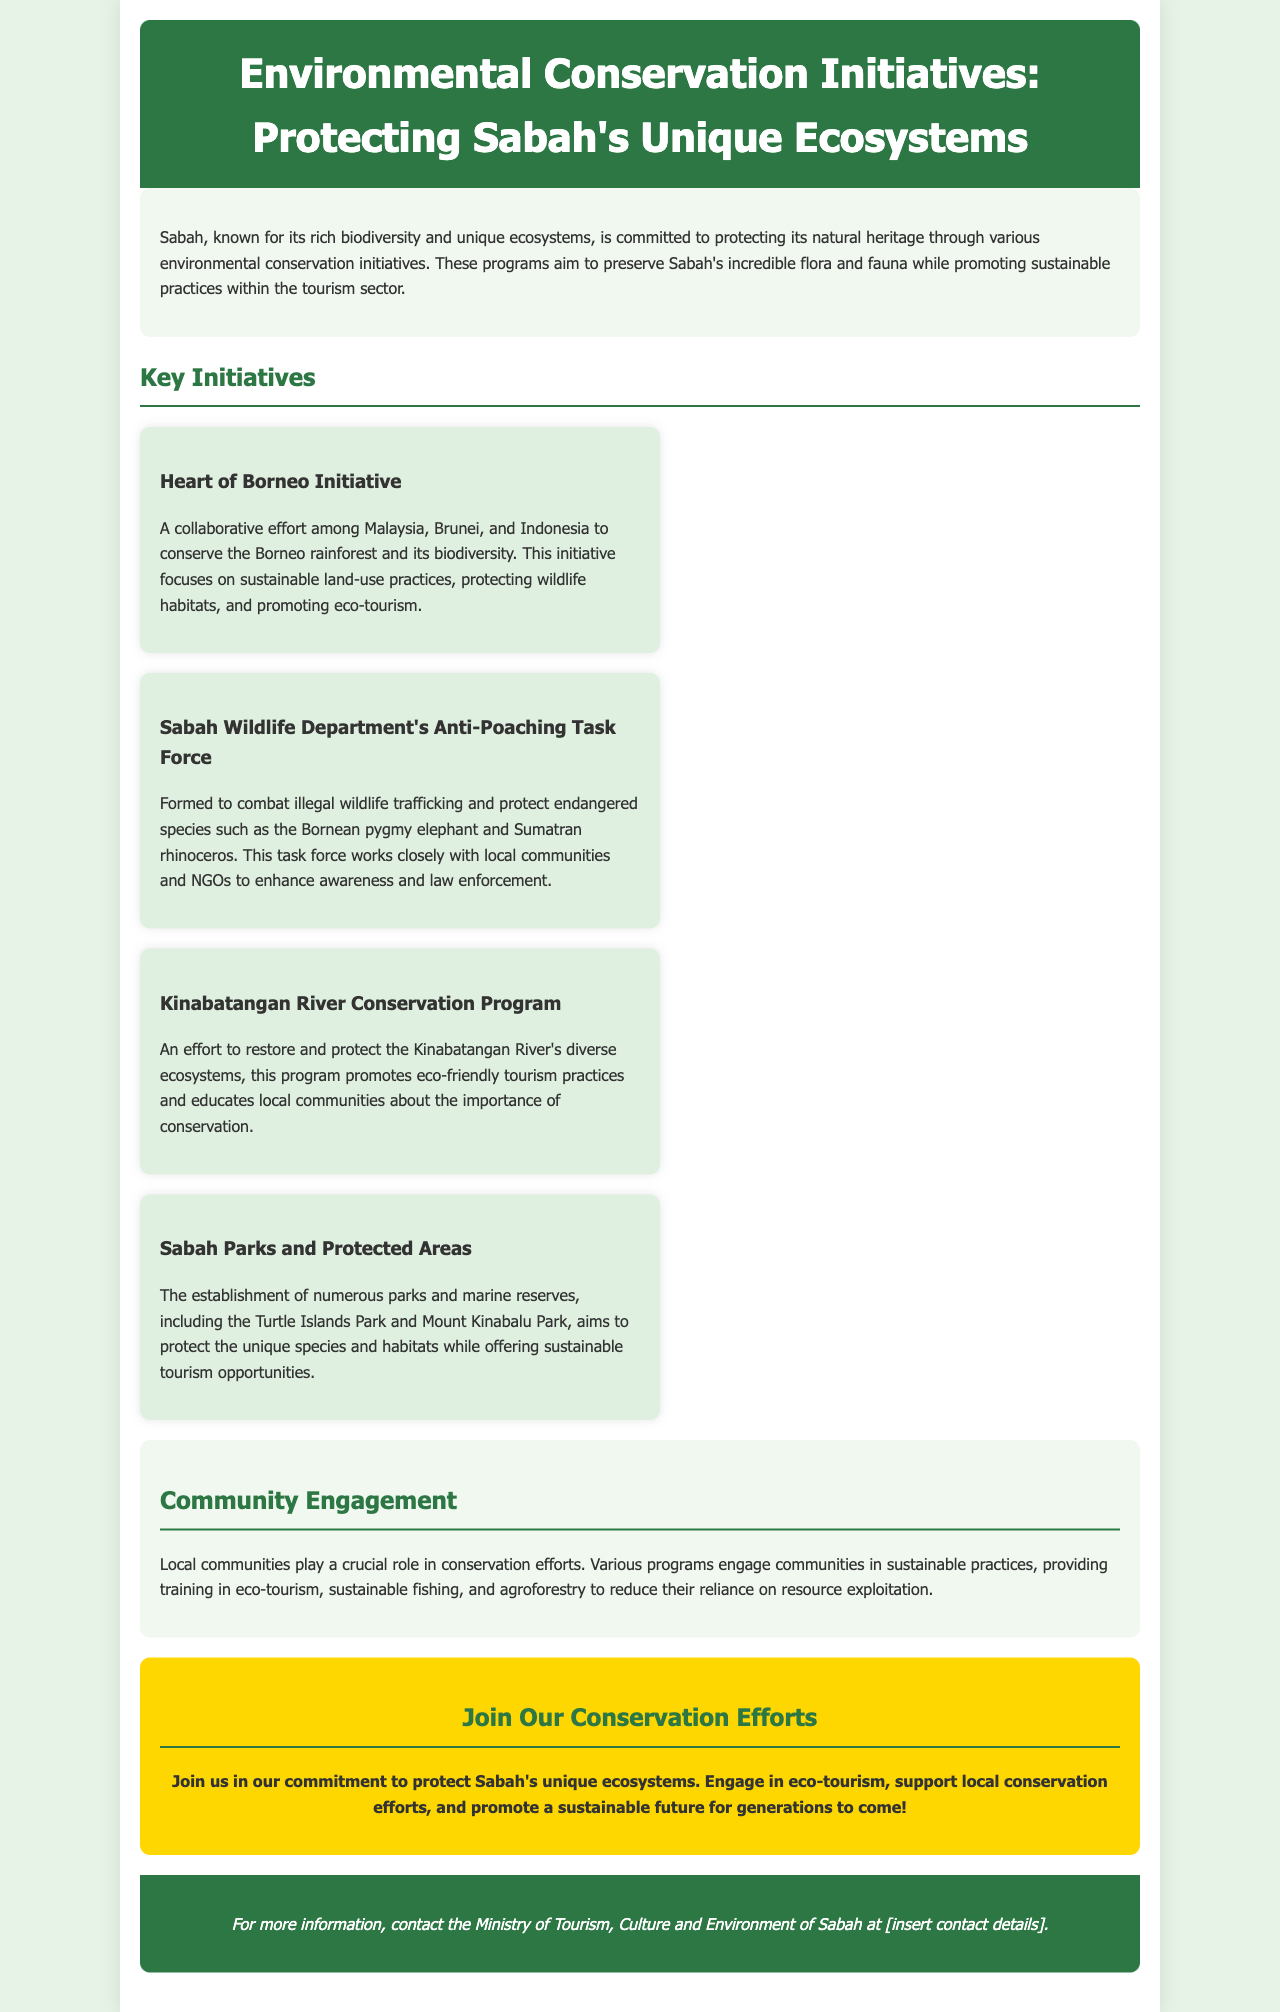What is the title of the document? The title of the document is specified in the header section of the brochure.
Answer: Environmental Conservation Initiatives: Protecting Sabah's Unique Ecosystems What is the first initiative listed? The first initiative listed focuses on collaborative conservation efforts among Malaysia, Brunei, and Indonesia.
Answer: Heart of Borneo Initiative What endangered species is specifically mentioned in the brochure? The brochure lists endangered species that are protected by the Anti-Poaching Task Force.
Answer: Bornean pygmy elephant and Sumatran rhinoceros How many key initiatives are mentioned in the document? The document lists a total of four key initiatives aimed at environmental conservation.
Answer: Four What role do local communities play in conservation efforts according to the document? The document explains that local communities are engaged in sustainable practices, reducing reliance on resource exploitation.
Answer: Crucial role What type of tourism is promoted through the programs? The brochure emphasizes the promotion of eco-friendly tourism practices as part of the conservation efforts.
Answer: Eco-tourism What is the call to action for readers? The brochure encourages readers to participate in activities that support ecosystem protection and sustainability.
Answer: Join Our Conservation Efforts Which park is mentioned as part of the protected areas? The brochure includes mentions of several protected areas, one of which is a well-known park in Sabah.
Answer: Mount Kinabalu Park What color is the header background? The color of the header background is specified in the CSS section and is visually represented in the rendered document.
Answer: Dark green 